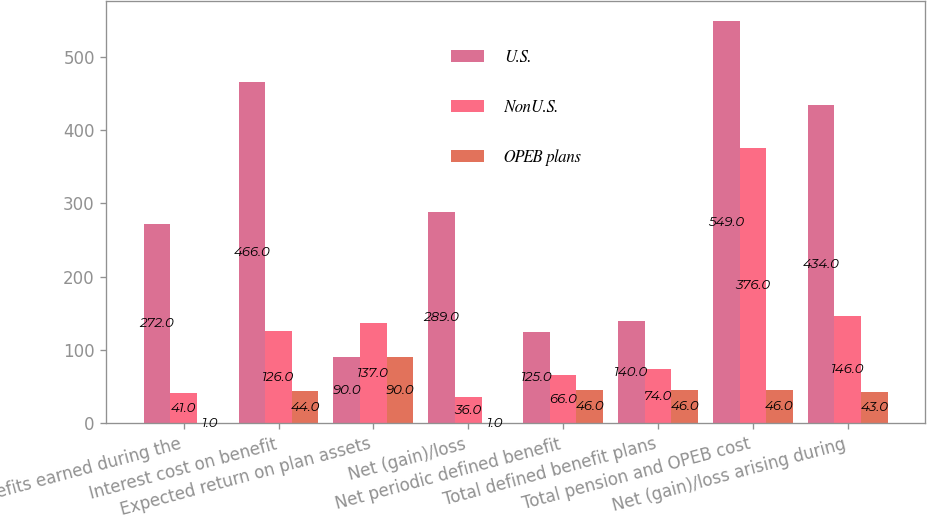Convert chart. <chart><loc_0><loc_0><loc_500><loc_500><stacked_bar_chart><ecel><fcel>Benefits earned during the<fcel>Interest cost on benefit<fcel>Expected return on plan assets<fcel>Net (gain)/loss<fcel>Net periodic defined benefit<fcel>Total defined benefit plans<fcel>Total pension and OPEB cost<fcel>Net (gain)/loss arising during<nl><fcel>U.S.<fcel>272<fcel>466<fcel>90<fcel>289<fcel>125<fcel>140<fcel>549<fcel>434<nl><fcel>NonU.S.<fcel>41<fcel>126<fcel>137<fcel>36<fcel>66<fcel>74<fcel>376<fcel>146<nl><fcel>OPEB plans<fcel>1<fcel>44<fcel>90<fcel>1<fcel>46<fcel>46<fcel>46<fcel>43<nl></chart> 